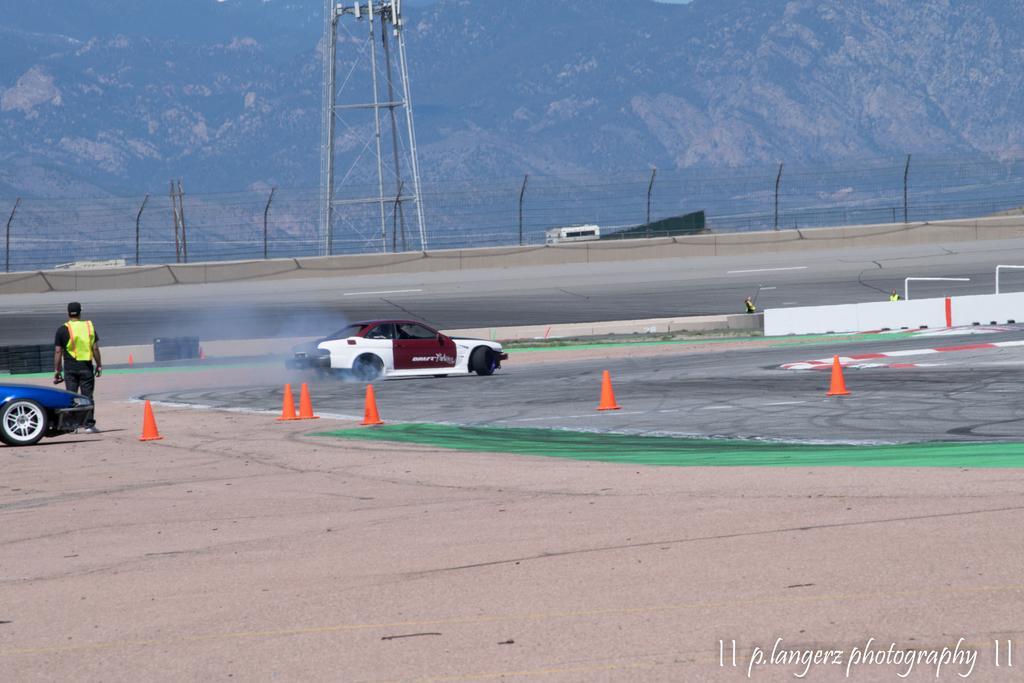Describe this image in one or two sentences. In this image I can see a text, two cars, stoppers and a person is standing on the road. In the background I can see a fence, tower and mountains. This image is taken may be during a day. 